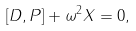Convert formula to latex. <formula><loc_0><loc_0><loc_500><loc_500>[ D , P ] + \omega ^ { 2 } X = 0 ,</formula> 